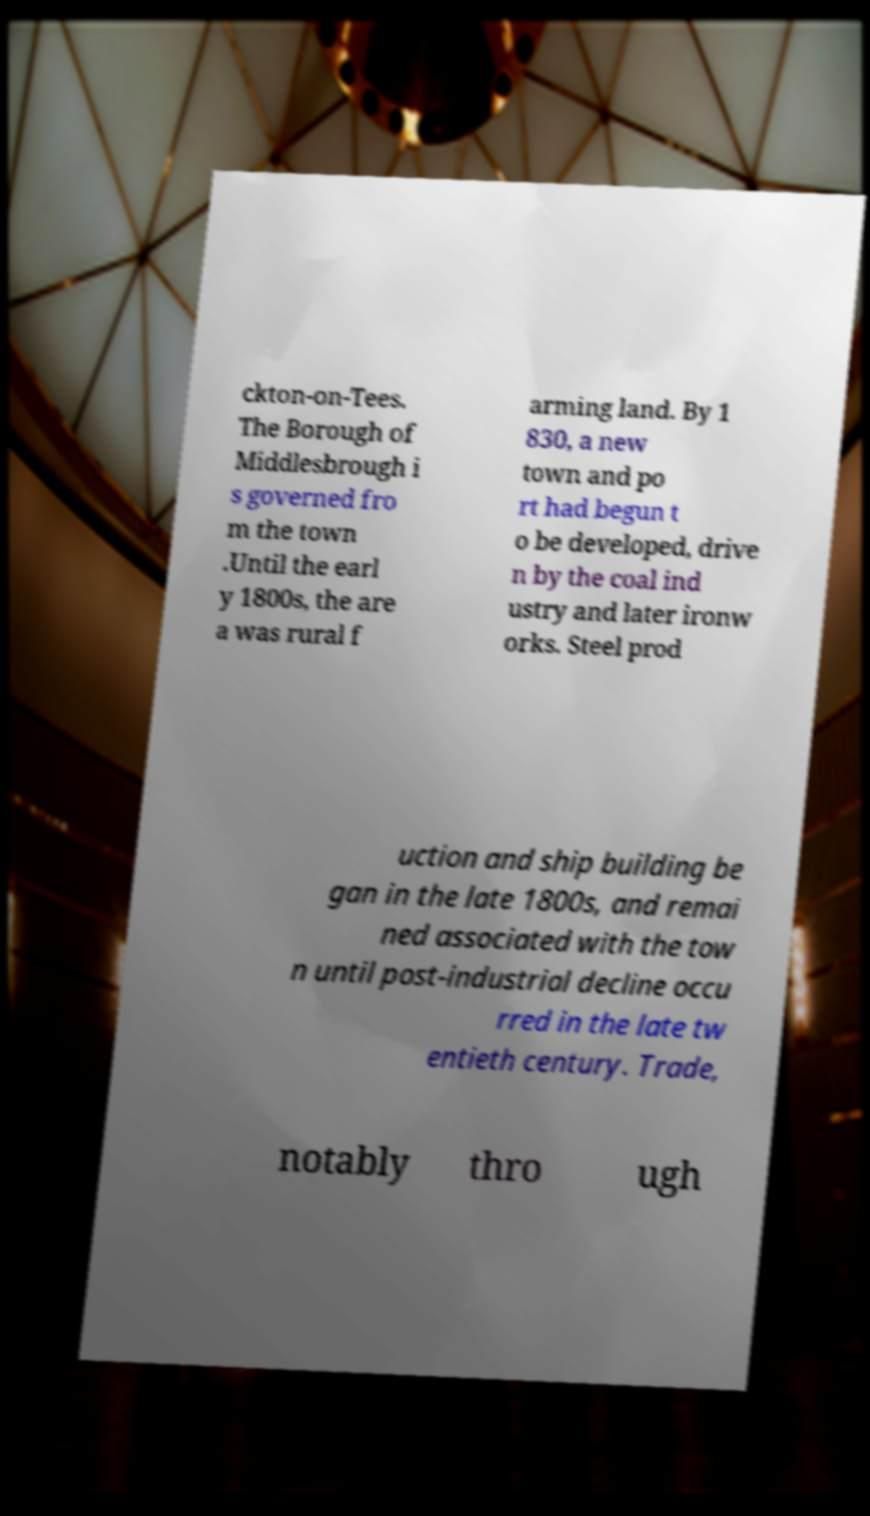Please identify and transcribe the text found in this image. ckton-on-Tees. The Borough of Middlesbrough i s governed fro m the town .Until the earl y 1800s, the are a was rural f arming land. By 1 830, a new town and po rt had begun t o be developed, drive n by the coal ind ustry and later ironw orks. Steel prod uction and ship building be gan in the late 1800s, and remai ned associated with the tow n until post-industrial decline occu rred in the late tw entieth century. Trade, notably thro ugh 